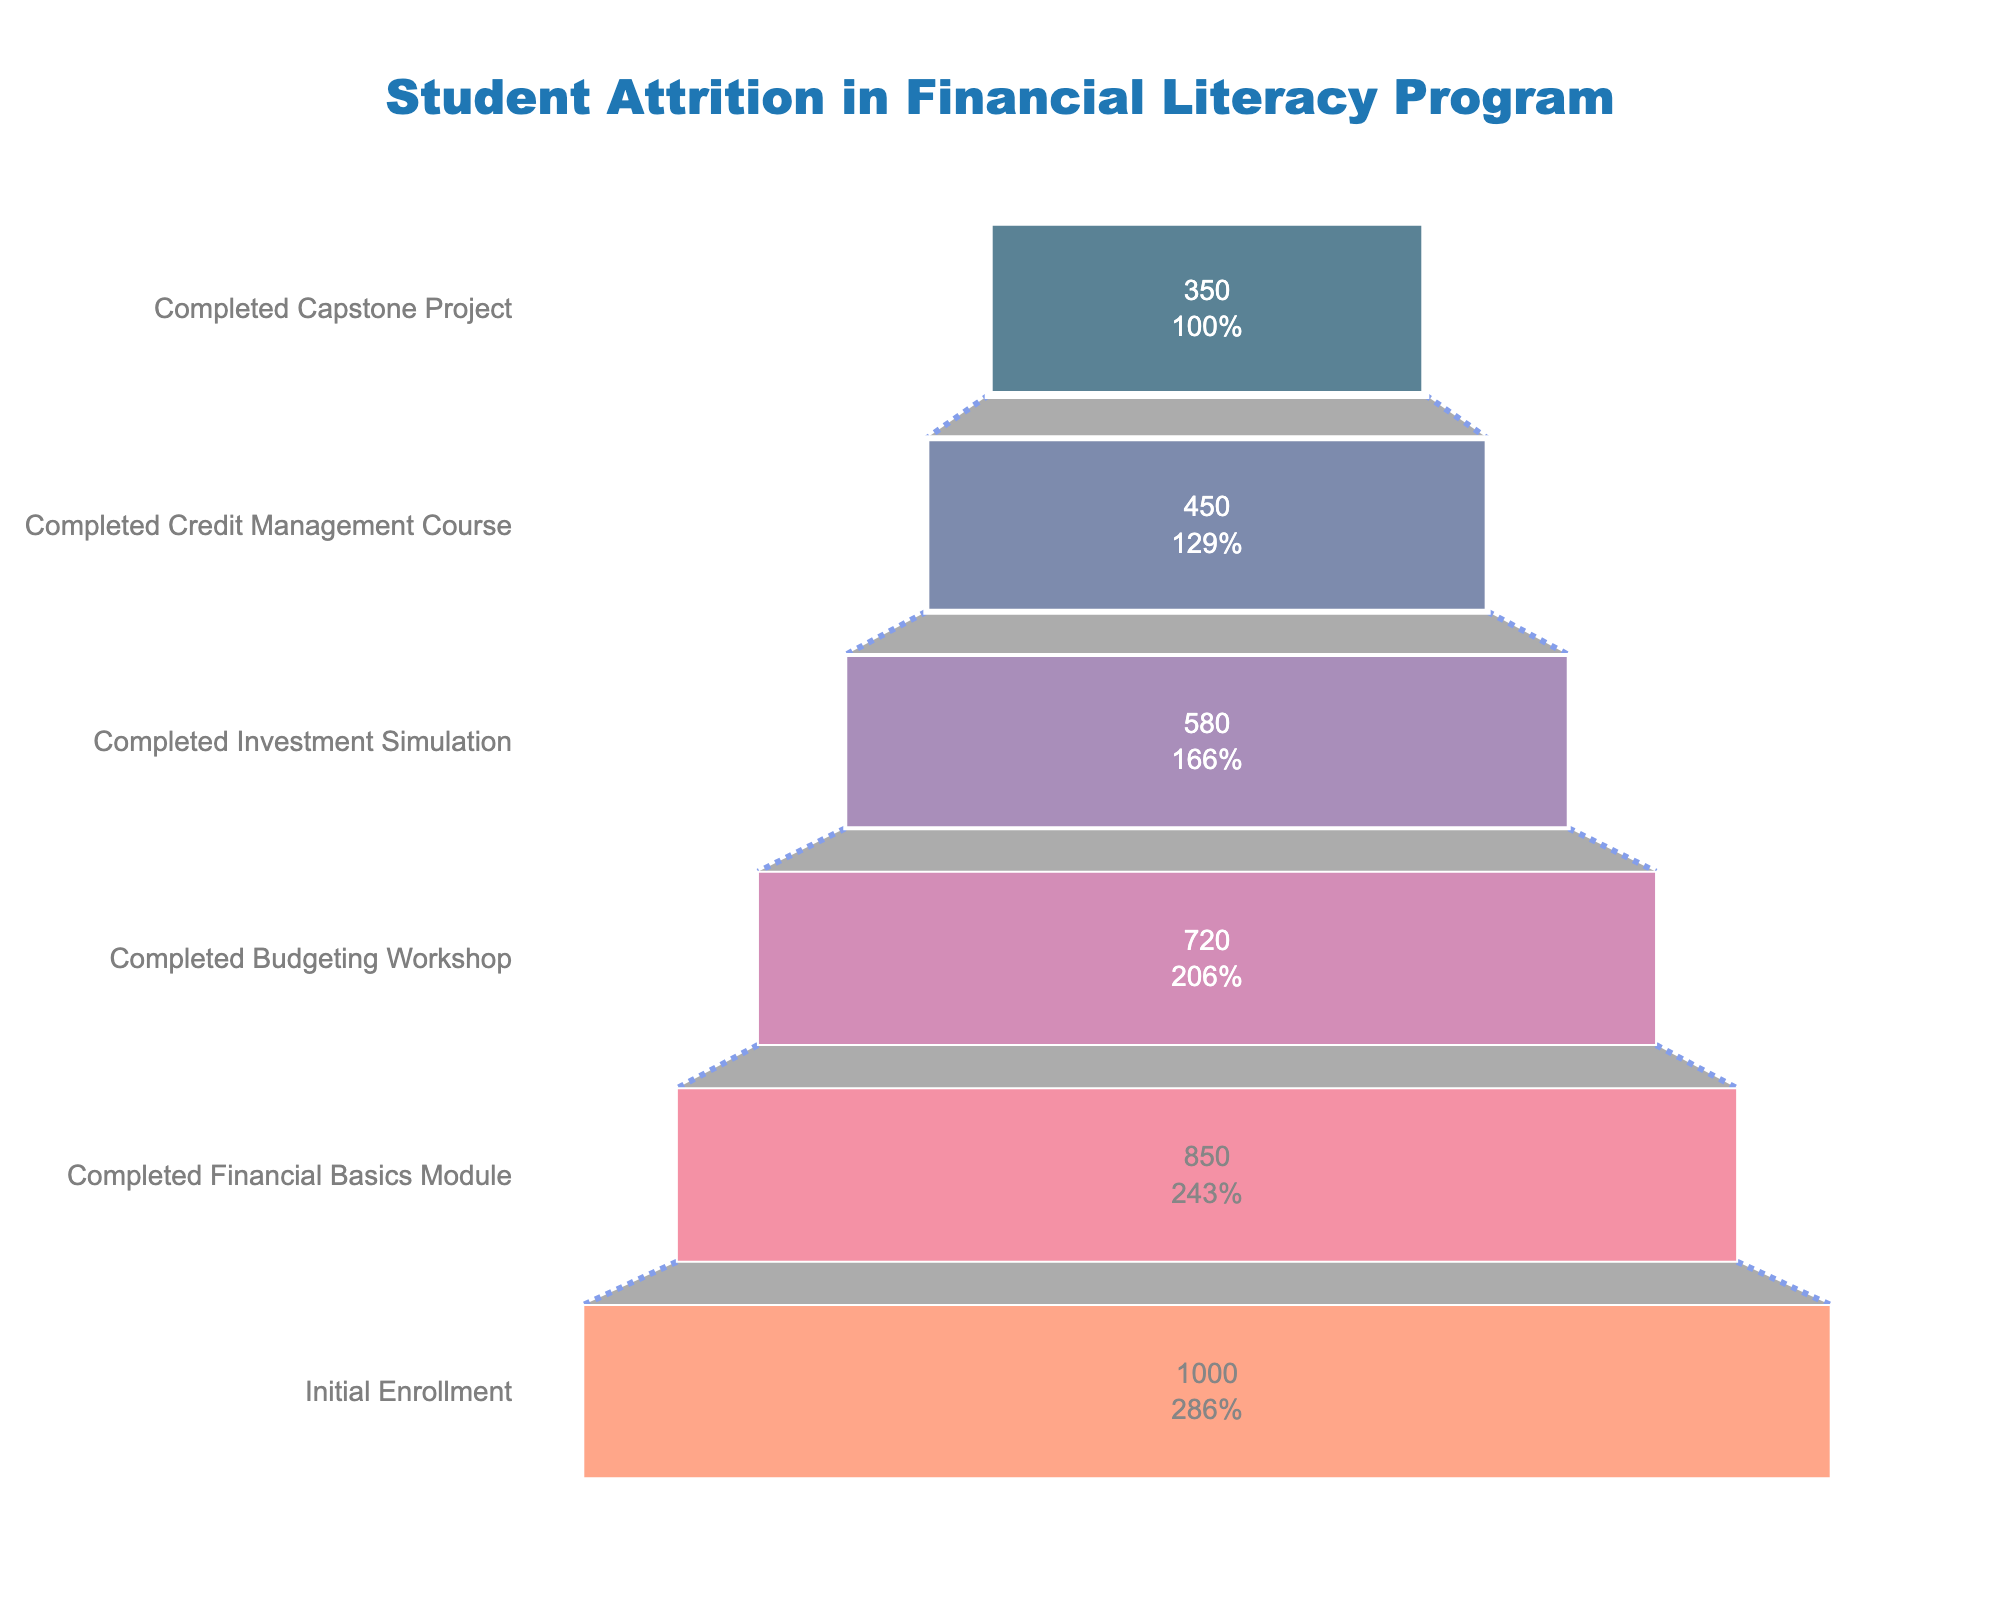What is the title of the funnel chart? The title of the funnel chart is located at the top of the figure. It reads "Student Attrition in Financial Literacy Program".
Answer: Student Attrition in Financial Literacy Program At which phase did the most significant drop in student numbers occur? Referring to the data points on the funnel chart, the most significant drop in student numbers occurred between "Completed Budgeting Workshop" with 720 students and "Completed Investment Simulation" with 580 students, which is a drop of 140 students.
Answer: Between Budgeting Workshop and Investment Simulation What is the percentage of students who completed the Capstone Project compared to the initial enrollment? The funnel chart displays the initial enrollment as 1000 and the students who completed the Capstone Project as 350. The percentage can be calculated as (350/1000) * 100%, which is 35%.
Answer: 35% How many students dropped out after completing the Investment Simulation? The number of students who completed the Investment Simulation is 580, and those who completed the next phase, Credit Management Course, are 450. Therefore, the number of students who dropped out is 580 - 450, which is 130 students.
Answer: 130 Which phase has the lowest student retention? The phase with the lowest number of students, according to the funnel chart, is the "Completed Capstone Project" with 350 students.
Answer: Completed Capstone Project Compare the number of students who completed the Financial Basics Module with those who completed the Investment Simulation. Referring to the funnel chart, 850 students completed the Financial Basics Module, whereas 580 students completed the Investment Simulation. A comparison of these values shows the Financial Basics Module had a higher completion number.
Answer: Financial Basics Module had more students Calculate the average number of students between the phases listed. The phases listed are "Initial Enrollment" (1000), "Completed Financial Basics Module" (850), "Completed Budgeting Workshop" (720), "Completed Investment Simulation" (580), "Completed Credit Management Course" (450), and "Completed Capstone Project" (350). The average can be calculated as (1000 + 850 + 720 + 580 + 450 + 350) / 6, which is 658.33.
Answer: 658.33 What is the percentage drop in student numbers after completing the Credit Management Course compared to those who completed the Budgeting Workshop? The number of students completing the Budgeting Workshop is 720, and those completing the Credit Management Course is 450. The percentage drop can be calculated as [(720 - 450) / 720] * 100%, which is approximately 37.5%.
Answer: 37.5% 